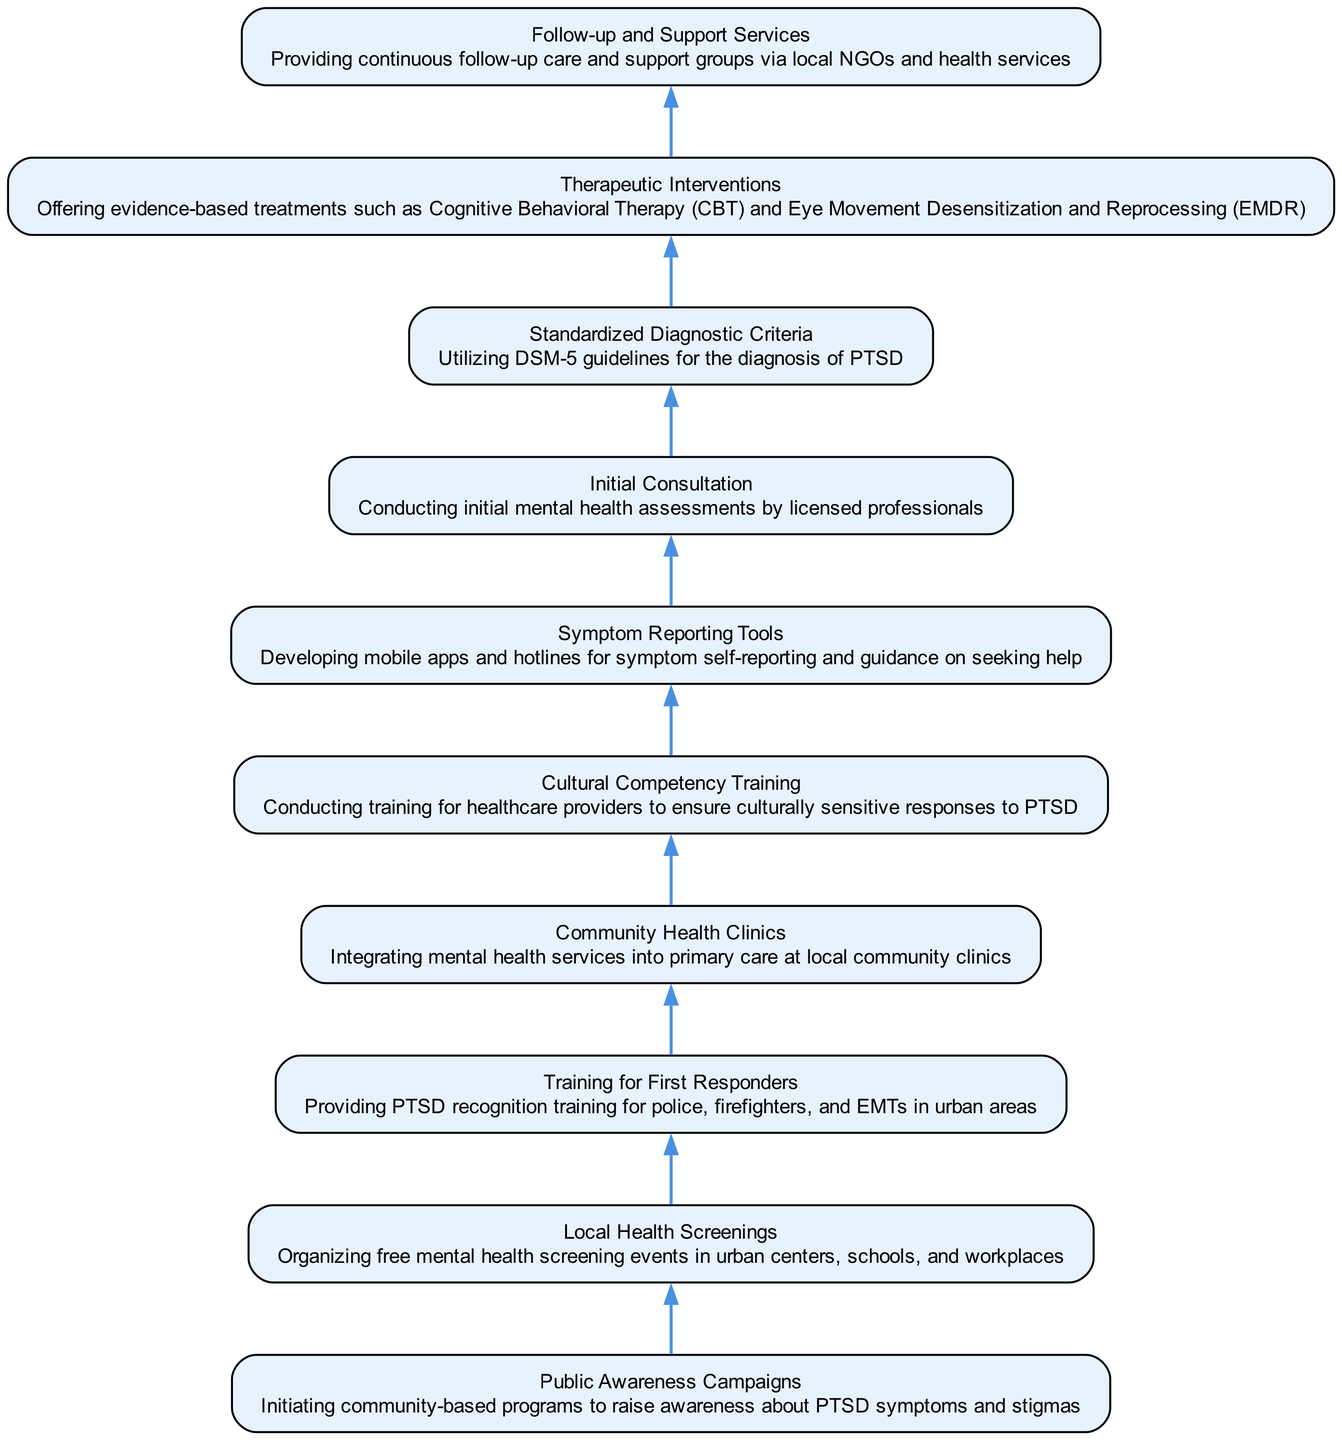What is the first step in identifying PTSD according to the diagram? The diagram shows "Public Awareness Campaigns" as the first node, indicating that the starting step involves raising awareness about PTSD.
Answer: Public Awareness Campaigns How many nodes are present in the diagram? Counting each unique step from "Public Awareness Campaigns" to "Follow-up and Support Services", there are 10 nodes in total outlining different aspects of identification and diagnosis.
Answer: 10 What follows "Local Health Screenings" in the diagram? The next node after "Local Health Screenings" is "Training for First Responders", indicating the sequence of actions taken after health screenings.
Answer: Training for First Responders What is the purpose of "Symptom Reporting Tools"? The description of "Symptom Reporting Tools" indicates that it is designed for self-reporting of symptoms and guidance on seeking help, which aids in the identification process.
Answer: Developing mobile apps and hotlines for symptom self-reporting and guidance on seeking help What is the relationship between "Initial Consultation" and "Standardized Diagnostic Criteria"? The flow from "Initial Consultation" to "Standardized Diagnostic Criteria" suggests that initial assessments lead to the application of DSM-5 guidelines for diagnosing PTSD.
Answer: Initial assessments lead to the application of DSM-5 guidelines Which node is located at the top of the diagram? The top node in a flow from bottom to up diagram structure is "Follow-up and Support Services", indicating this is the final step in the process.
Answer: Follow-up and Support Services What do "Cultural Competency Training" and "Therapeutic Interventions" have in common? Both nodes focus on enhancing the response to PTSD; one through training health providers for culturally sensitive care and the other through offering evidence-based treatments for those diagnosed.
Answer: Both focus on enhancing response to PTSD How does the flow of the diagram progress from "Community Health Clinics"? The next progression after "Community Health Clinics" in the flow is "Initial Consultation", indicating the sequence of providing integrated mental health services leading to professional assessments.
Answer: Progresses to Initial Consultation What action is taken after "Training for First Responders"? After "Training for First Responders", the flow continues to "Community Health Clinics", indicating that trained responders facilitate access to mental health services.
Answer: Proceeds to Community Health Clinics 